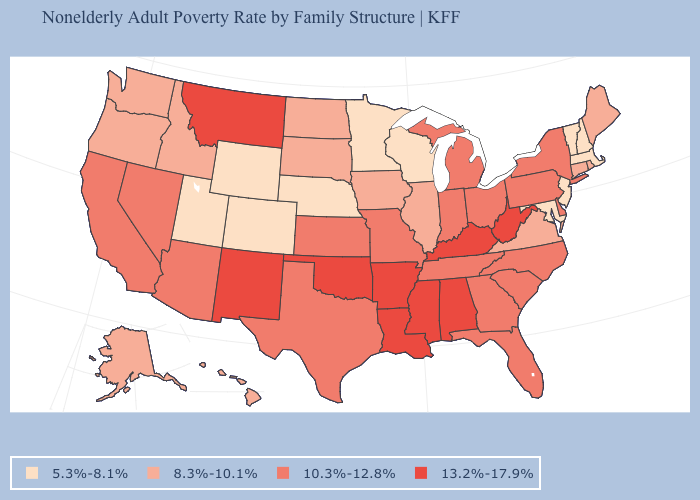Among the states that border Connecticut , which have the highest value?
Concise answer only. New York. Does Kansas have the same value as Michigan?
Quick response, please. Yes. How many symbols are there in the legend?
Answer briefly. 4. What is the value of California?
Answer briefly. 10.3%-12.8%. Does the first symbol in the legend represent the smallest category?
Quick response, please. Yes. Name the states that have a value in the range 5.3%-8.1%?
Be succinct. Colorado, Maryland, Massachusetts, Minnesota, Nebraska, New Hampshire, New Jersey, Utah, Vermont, Wisconsin, Wyoming. Which states hav the highest value in the Northeast?
Write a very short answer. New York, Pennsylvania. Does Ohio have a higher value than Maryland?
Concise answer only. Yes. Which states have the lowest value in the South?
Give a very brief answer. Maryland. Name the states that have a value in the range 13.2%-17.9%?
Be succinct. Alabama, Arkansas, Kentucky, Louisiana, Mississippi, Montana, New Mexico, Oklahoma, West Virginia. What is the highest value in the USA?
Concise answer only. 13.2%-17.9%. What is the value of Missouri?
Give a very brief answer. 10.3%-12.8%. Does Massachusetts have a higher value than Vermont?
Keep it brief. No. What is the value of West Virginia?
Concise answer only. 13.2%-17.9%. What is the highest value in the Northeast ?
Give a very brief answer. 10.3%-12.8%. 